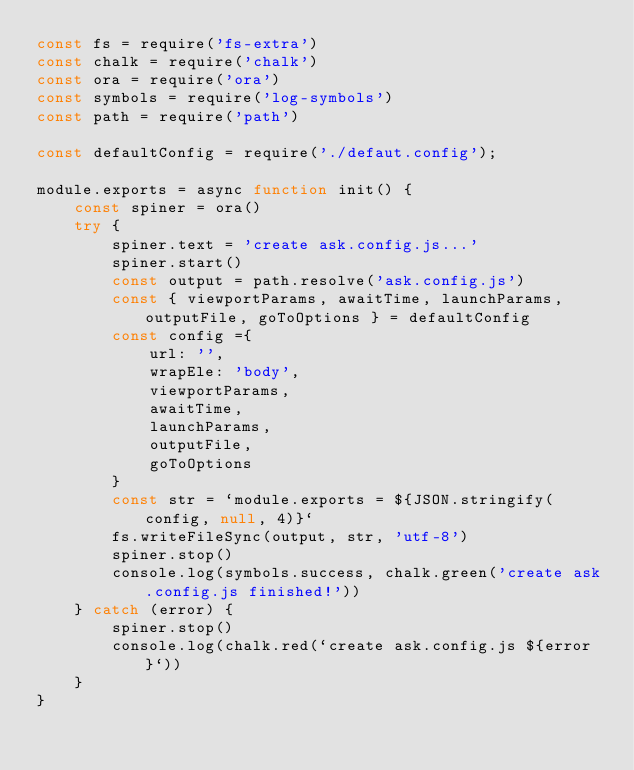Convert code to text. <code><loc_0><loc_0><loc_500><loc_500><_JavaScript_>const fs = require('fs-extra')
const chalk = require('chalk')
const ora = require('ora')
const symbols = require('log-symbols')
const path = require('path')

const defaultConfig = require('./defaut.config');

module.exports = async function init() {
    const spiner = ora()
    try {
        spiner.text = 'create ask.config.js...'
        spiner.start()
        const output = path.resolve('ask.config.js')
        const { viewportParams, awaitTime, launchParams, outputFile, goToOptions } = defaultConfig
        const config ={
            url: '',
            wrapEle: 'body',
            viewportParams,
            awaitTime,
            launchParams,
            outputFile,
            goToOptions
        }
        const str = `module.exports = ${JSON.stringify(config, null, 4)}`
        fs.writeFileSync(output, str, 'utf-8')
        spiner.stop()
        console.log(symbols.success, chalk.green('create ask.config.js finished!'))
    } catch (error) {
        spiner.stop()
        console.log(chalk.red(`create ask.config.js ${error}`))
    }
}</code> 